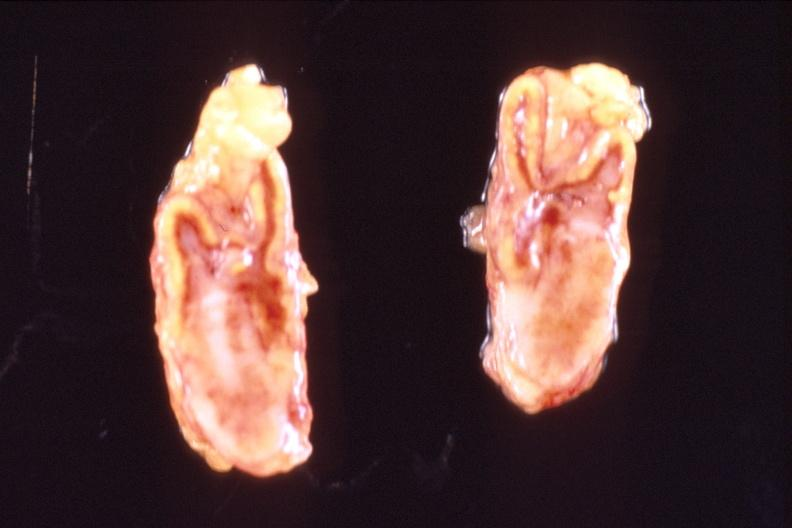does this image show adrenal glands, metastatic breast cancer?
Answer the question using a single word or phrase. Yes 